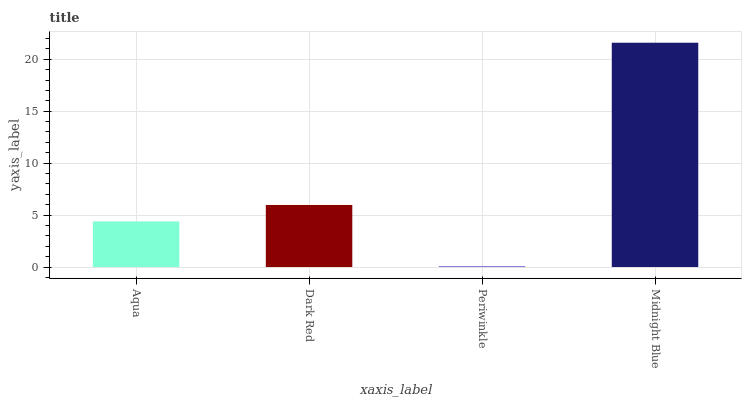Is Dark Red the minimum?
Answer yes or no. No. Is Dark Red the maximum?
Answer yes or no. No. Is Dark Red greater than Aqua?
Answer yes or no. Yes. Is Aqua less than Dark Red?
Answer yes or no. Yes. Is Aqua greater than Dark Red?
Answer yes or no. No. Is Dark Red less than Aqua?
Answer yes or no. No. Is Dark Red the high median?
Answer yes or no. Yes. Is Aqua the low median?
Answer yes or no. Yes. Is Midnight Blue the high median?
Answer yes or no. No. Is Midnight Blue the low median?
Answer yes or no. No. 